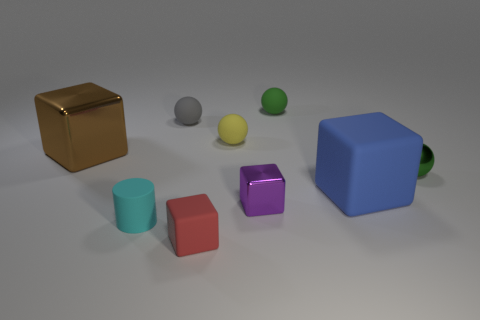The matte sphere that is the same color as the metallic ball is what size?
Offer a terse response. Small. There is a green object that is on the right side of the tiny green rubber ball; is it the same shape as the tiny yellow matte object?
Ensure brevity in your answer.  Yes. There is a large cube that is to the left of the small cyan cylinder; what is its material?
Your answer should be compact. Metal. There is a thing that is the same color as the shiny sphere; what is its shape?
Your answer should be compact. Sphere. Are there any small purple spheres made of the same material as the gray object?
Keep it short and to the point. No. The purple block is what size?
Provide a succinct answer. Small. What number of cyan objects are tiny metallic spheres or tiny rubber things?
Ensure brevity in your answer.  1. How many other things have the same shape as the tiny green metal object?
Your answer should be very brief. 3. What number of things have the same size as the gray ball?
Your answer should be very brief. 6. There is a purple thing that is the same shape as the large blue object; what is its material?
Your response must be concise. Metal. 